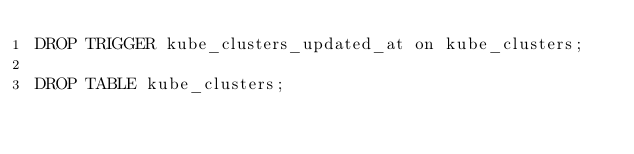<code> <loc_0><loc_0><loc_500><loc_500><_SQL_>DROP TRIGGER kube_clusters_updated_at on kube_clusters;

DROP TABLE kube_clusters;
</code> 